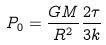<formula> <loc_0><loc_0><loc_500><loc_500>P _ { 0 } = \frac { G M } { R ^ { 2 } } \frac { 2 \tau } { 3 k }</formula> 